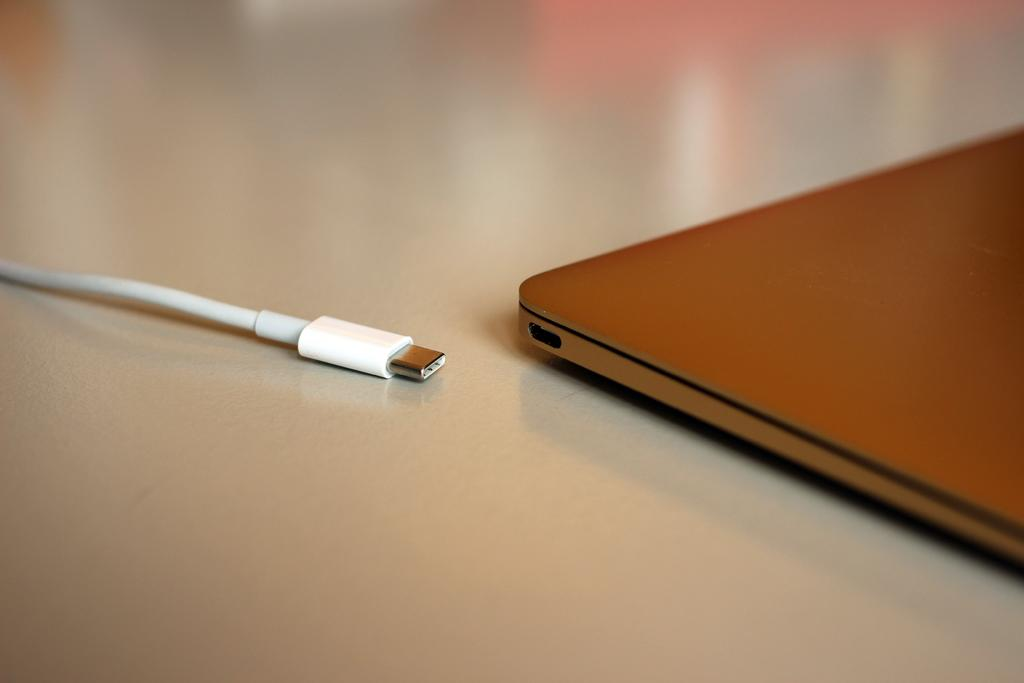What type of object is present on the table in the image? There is an electronic device in the image. What is connected to the electronic device in the image? There is a cable in the image. Where are the electronic device and the cable located? Both the electronic device and the cable are on a table. What type of pets are visible in the image? There are no pets visible in the image. What month is it in the image? The month is not mentioned or depicted in the image. 